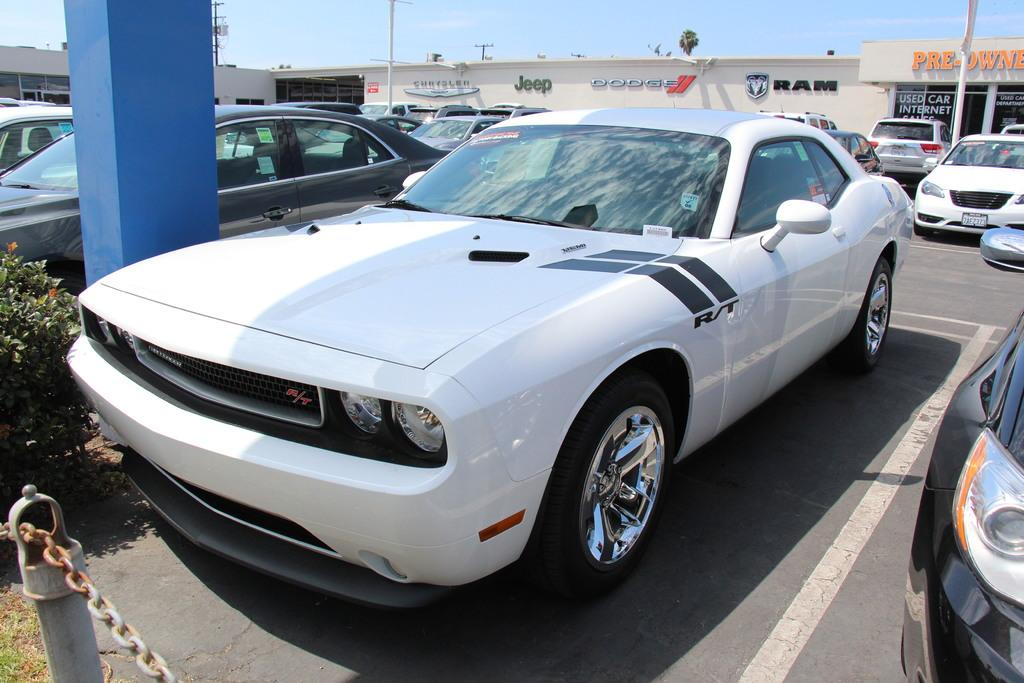What can be seen on the road in the image? There are cars parked on the road in the image. What type of structure is visible in the background? There is a house in the background of the image. What is visible at the top of the image? The sky is clear and visible at the top of the image. How many things can be counted in the image? The provided facts do not give information about counting specific items in the image. Is there a zoo present in the image? There is no mention of a zoo in the provided facts, and therefore it cannot be determined if one is present in the image. 